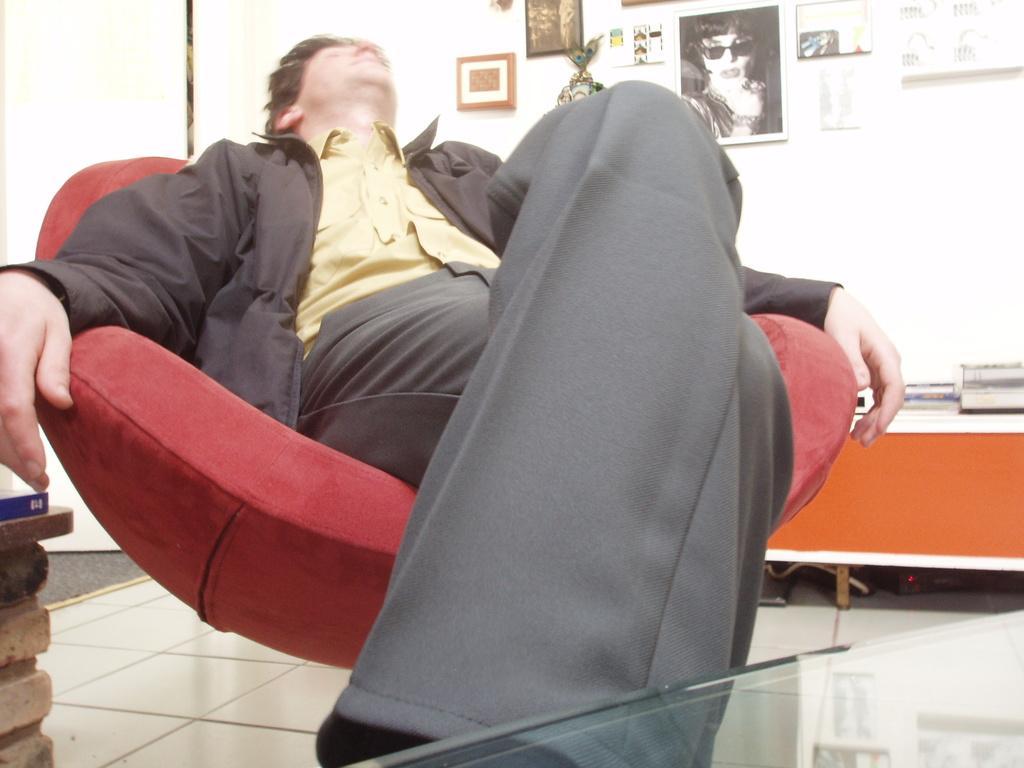Could you give a brief overview of what you see in this image? In this picture we can see men sitting on chair and beside to him we have frames to wall, table and on table we have books. 